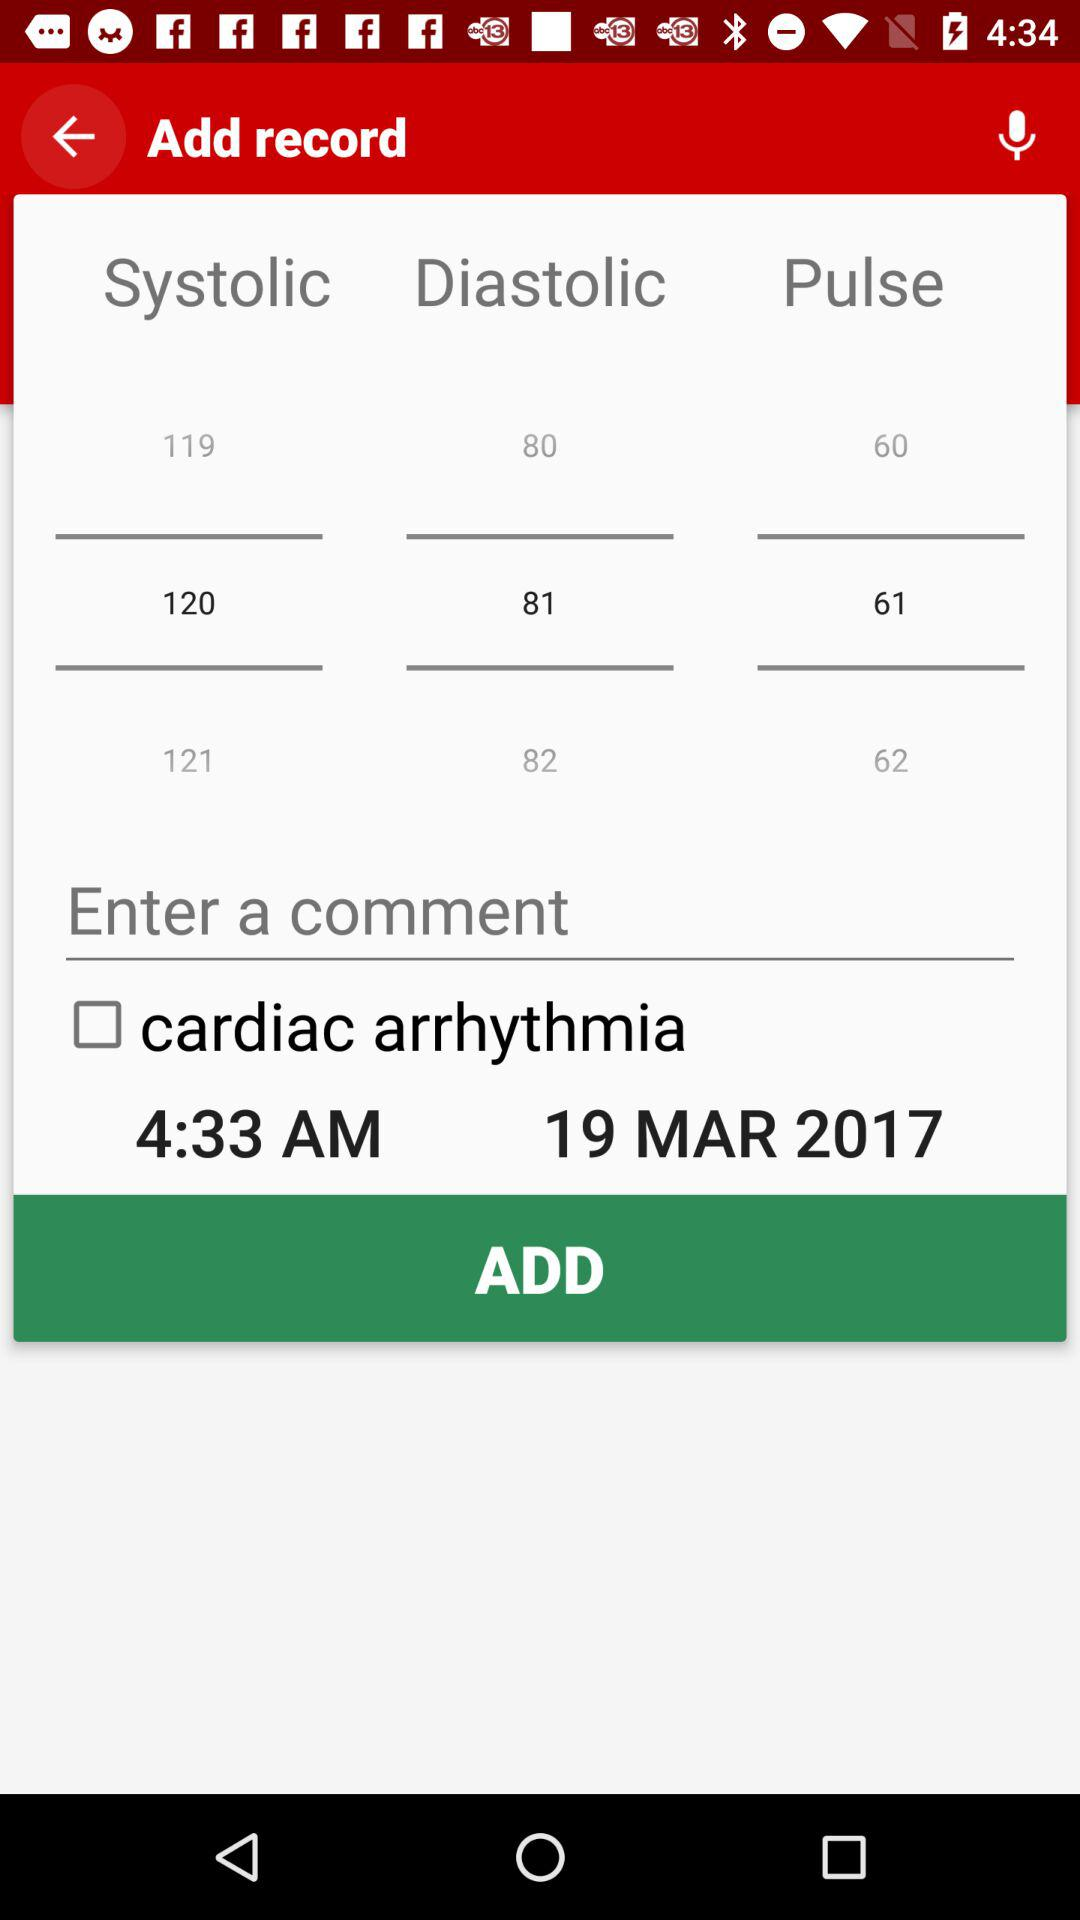Is "Enter a comment" checked or unchecked?
When the provided information is insufficient, respond with <no answer>. <no answer> 